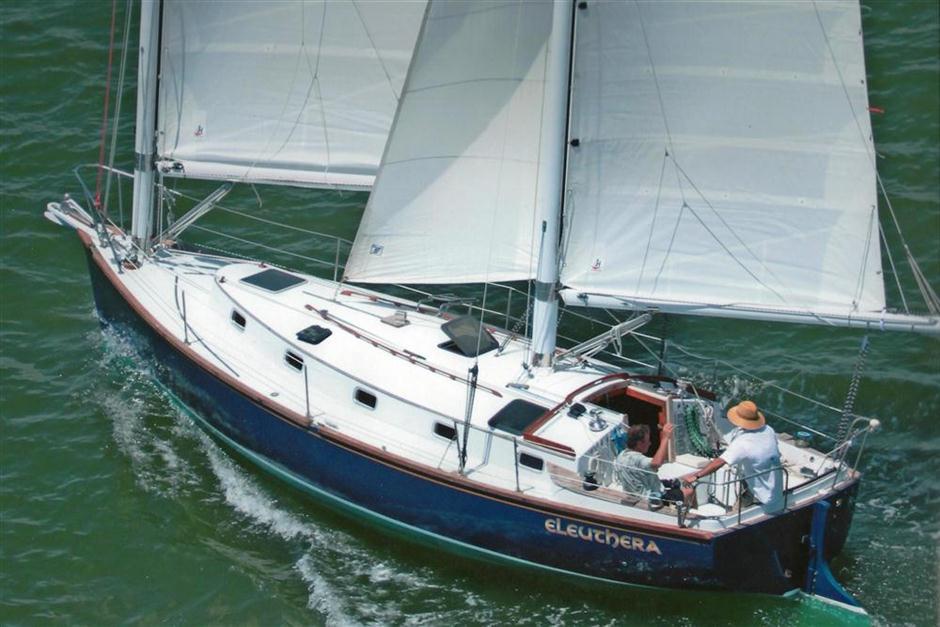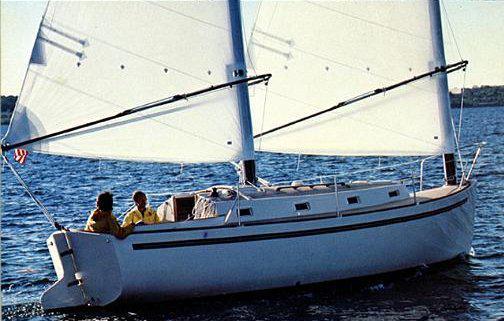The first image is the image on the left, the second image is the image on the right. For the images shown, is this caption "The boat in the left image has a blue hull, and the boats in the left and right images have their sails in the same position [furled or unfurled]." true? Answer yes or no. Yes. The first image is the image on the left, the second image is the image on the right. Considering the images on both sides, is "The left and right image contains a total of three boats." valid? Answer yes or no. No. 